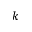Convert formula to latex. <formula><loc_0><loc_0><loc_500><loc_500>k</formula> 